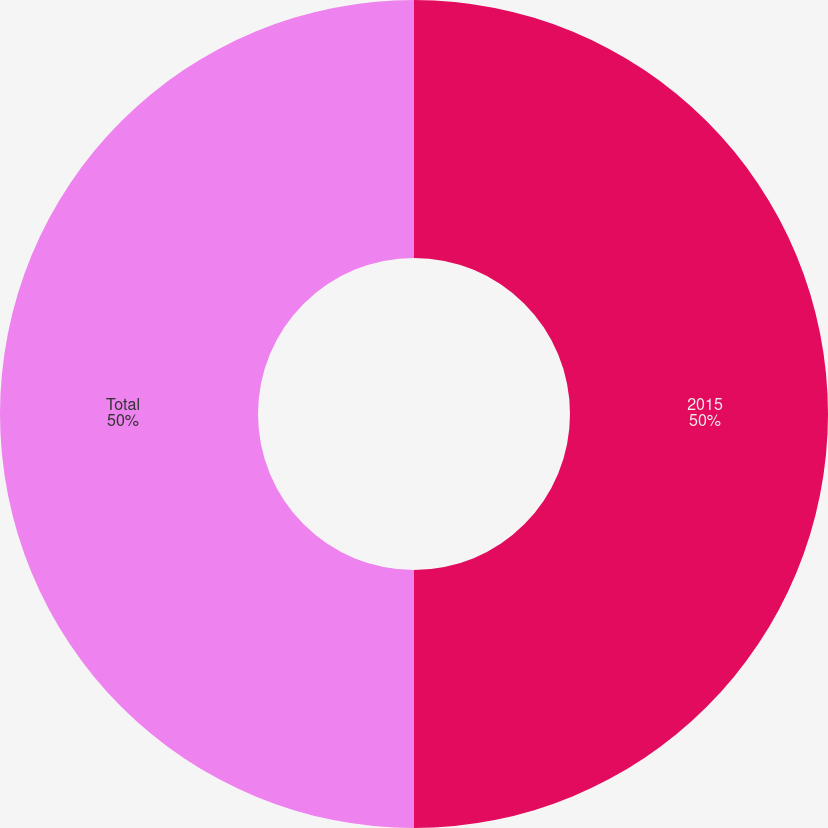Convert chart to OTSL. <chart><loc_0><loc_0><loc_500><loc_500><pie_chart><fcel>2015<fcel>Total<nl><fcel>50.0%<fcel>50.0%<nl></chart> 